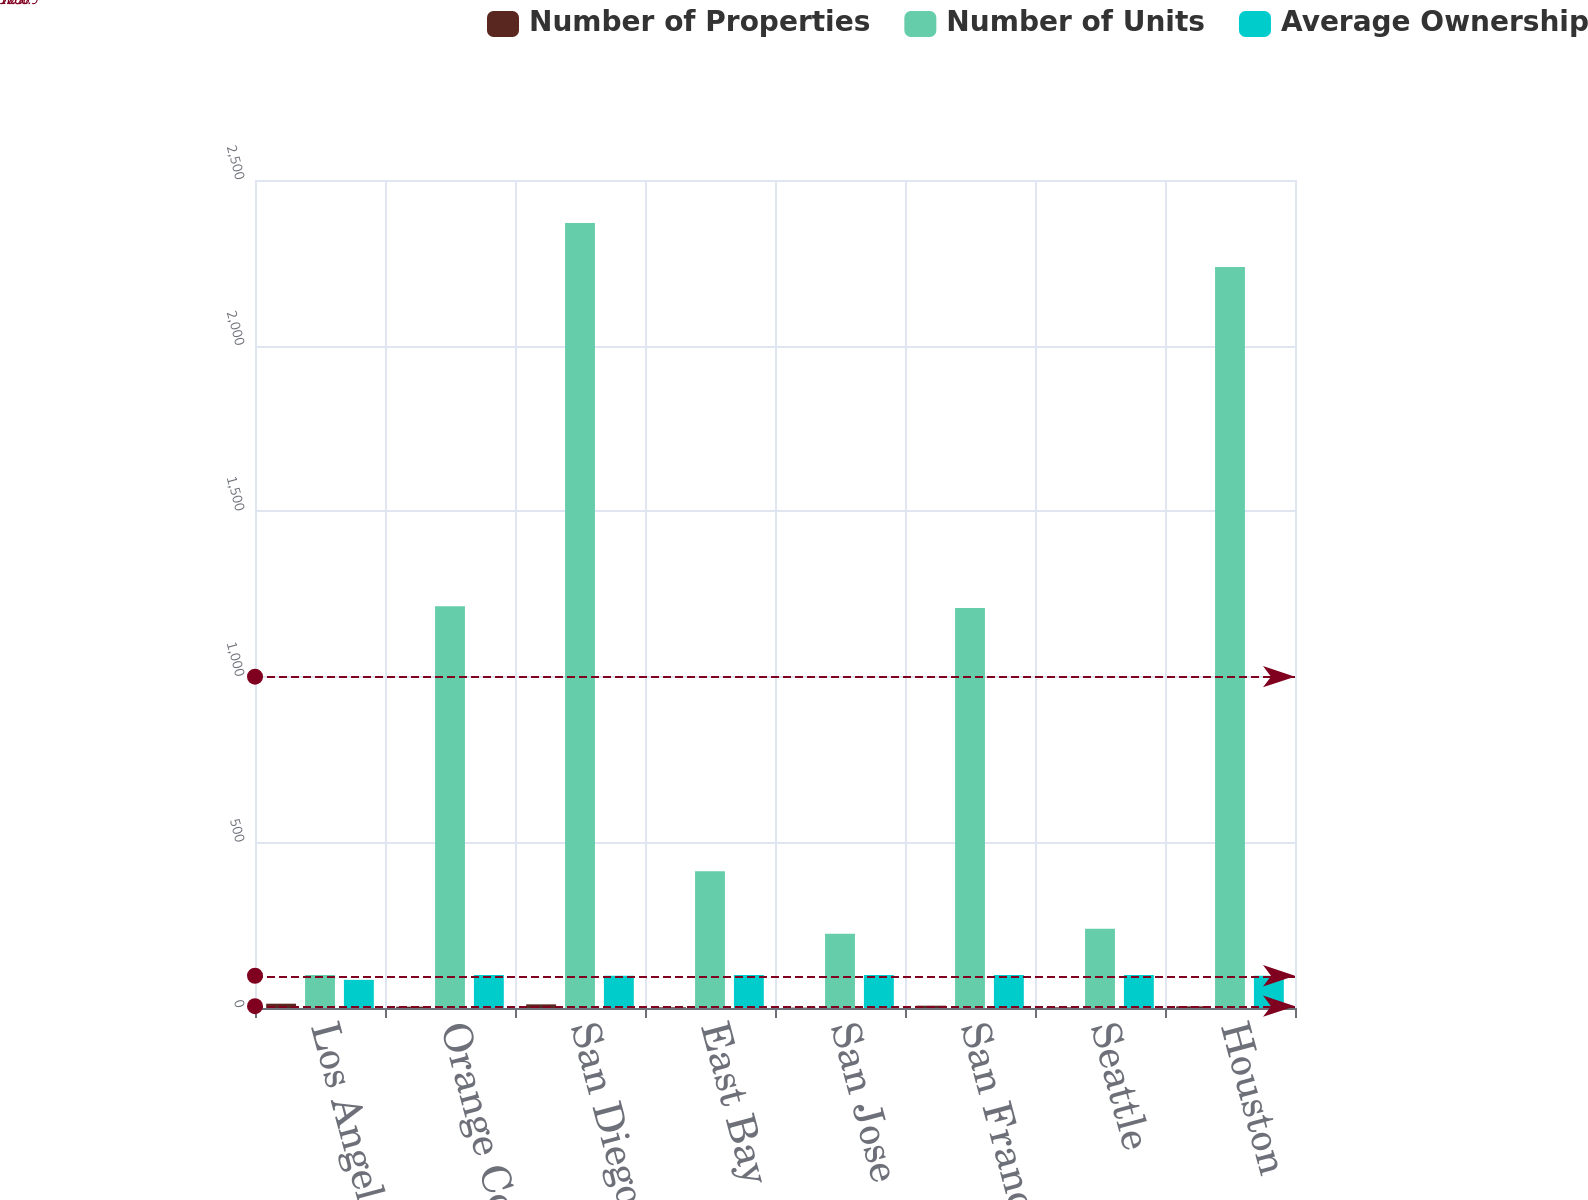<chart> <loc_0><loc_0><loc_500><loc_500><stacked_bar_chart><ecel><fcel>Los Angeles<fcel>Orange County<fcel>San Diego<fcel>East Bay<fcel>San Jose<fcel>San Francisco<fcel>Seattle<fcel>Houston<nl><fcel>Number of Properties<fcel>13<fcel>4<fcel>11<fcel>2<fcel>1<fcel>7<fcel>2<fcel>5<nl><fcel>Number of Units<fcel>100<fcel>1213<fcel>2370<fcel>413<fcel>224<fcel>1208<fcel>239<fcel>2237<nl><fcel>Average Ownership<fcel>85<fcel>100<fcel>97<fcel>100<fcel>100<fcel>100<fcel>100<fcel>97<nl></chart> 